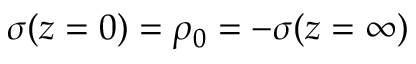Convert formula to latex. <formula><loc_0><loc_0><loc_500><loc_500>\sigma ( z = 0 ) = \rho _ { 0 } = - \sigma ( z = \infty )</formula> 